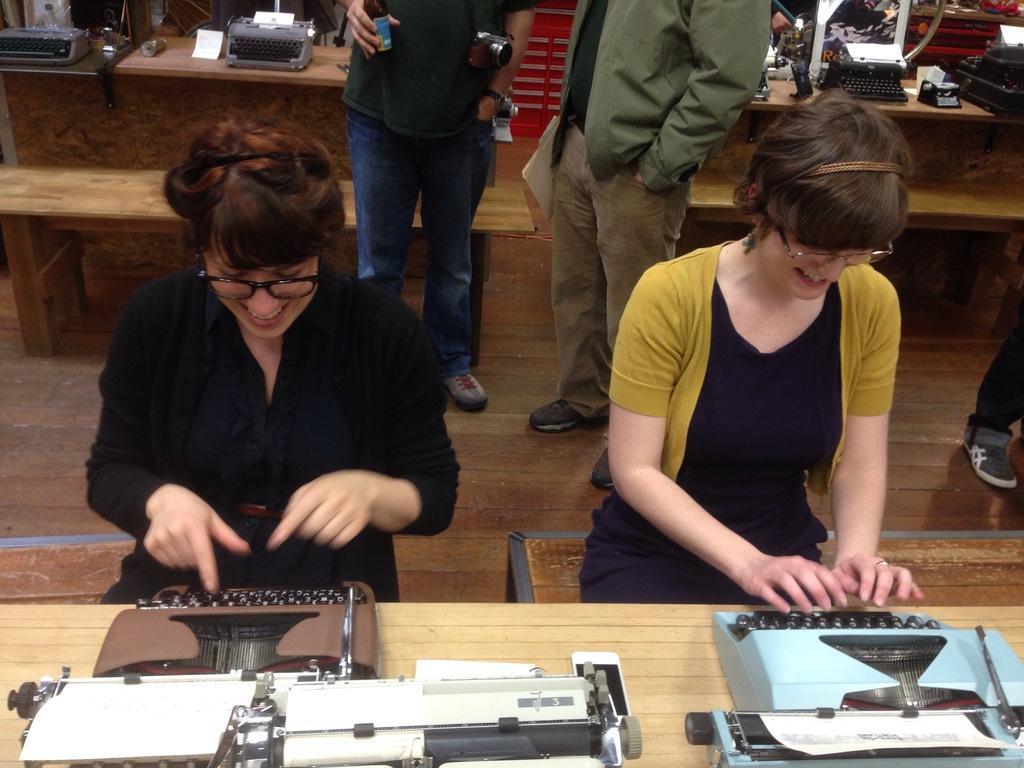Describe this image in one or two sentences. This picture is clicked inside. In the foreground there is a wooden table on the top of which we can see the two typewriters are placed and there are two women smiling, sitting on the benches and typing. In the center there are two persons standing on the ground. In the background we can see the tables on the of the top of which typewriters, books and many other items are placed and we can see some other objects. 